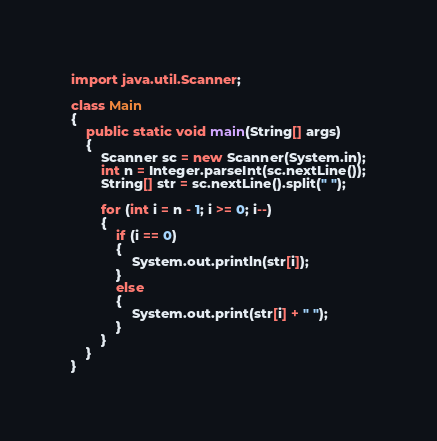<code> <loc_0><loc_0><loc_500><loc_500><_Java_>import java.util.Scanner;

class Main
{
	public static void main(String[] args)
	{
		Scanner sc = new Scanner(System.in);
		int n = Integer.parseInt(sc.nextLine());
		String[] str = sc.nextLine().split(" ");
		
		for (int i = n - 1; i >= 0; i--)
		{
			if (i == 0)
			{
				System.out.println(str[i]);
			}
			else
			{
				System.out.print(str[i] + " ");
			}
		}
	}
}</code> 